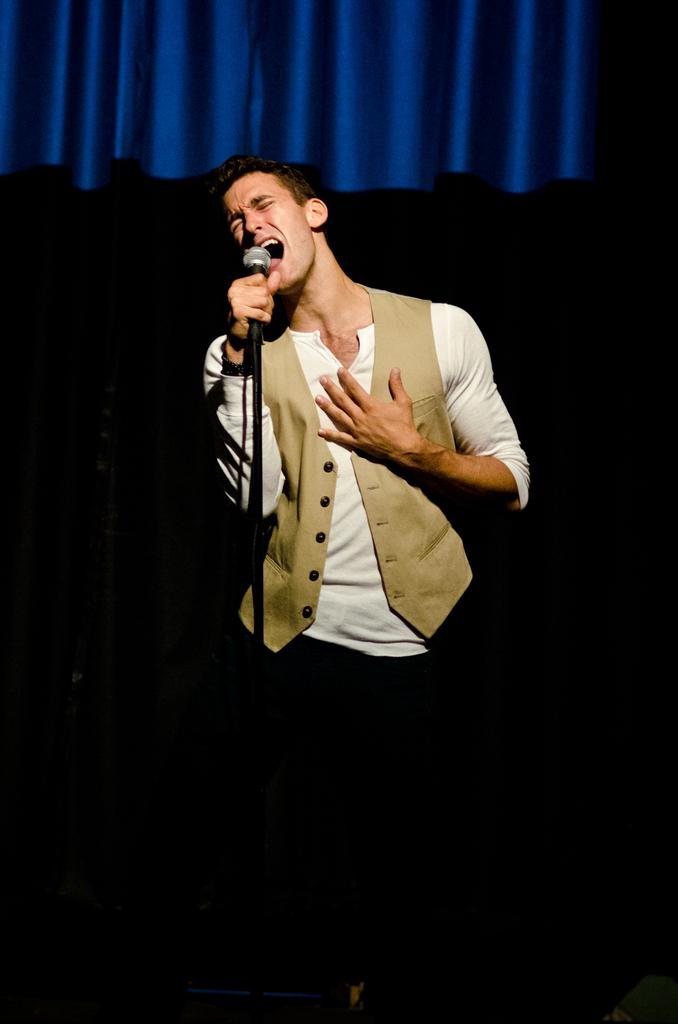What is the person in the image doing? The person is standing in front of a mic. How would you describe the lighting in the image? The background of the image is dark. Can you identify any specific features of the setting? There is a curtain at the top of the image. What is the price of the skin care product being advertised in the image? There is no skin care product or price mentioned in the image; it features a person standing in front of a mic. 